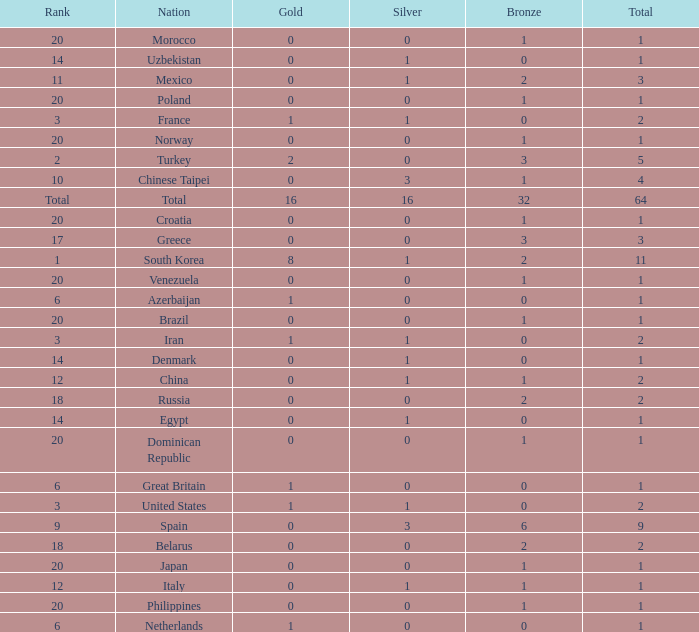Help me parse the entirety of this table. {'header': ['Rank', 'Nation', 'Gold', 'Silver', 'Bronze', 'Total'], 'rows': [['20', 'Morocco', '0', '0', '1', '1'], ['14', 'Uzbekistan', '0', '1', '0', '1'], ['11', 'Mexico', '0', '1', '2', '3'], ['20', 'Poland', '0', '0', '1', '1'], ['3', 'France', '1', '1', '0', '2'], ['20', 'Norway', '0', '0', '1', '1'], ['2', 'Turkey', '2', '0', '3', '5'], ['10', 'Chinese Taipei', '0', '3', '1', '4'], ['Total', 'Total', '16', '16', '32', '64'], ['20', 'Croatia', '0', '0', '1', '1'], ['17', 'Greece', '0', '0', '3', '3'], ['1', 'South Korea', '8', '1', '2', '11'], ['20', 'Venezuela', '0', '0', '1', '1'], ['6', 'Azerbaijan', '1', '0', '0', '1'], ['20', 'Brazil', '0', '0', '1', '1'], ['3', 'Iran', '1', '1', '0', '2'], ['14', 'Denmark', '0', '1', '0', '1'], ['12', 'China', '0', '1', '1', '2'], ['18', 'Russia', '0', '0', '2', '2'], ['14', 'Egypt', '0', '1', '0', '1'], ['20', 'Dominican Republic', '0', '0', '1', '1'], ['6', 'Great Britain', '1', '0', '0', '1'], ['3', 'United States', '1', '1', '0', '2'], ['9', 'Spain', '0', '3', '6', '9'], ['18', 'Belarus', '0', '0', '2', '2'], ['20', 'Japan', '0', '0', '1', '1'], ['12', 'Italy', '0', '1', '1', '1'], ['20', 'Philippines', '0', '0', '1', '1'], ['6', 'Netherlands', '1', '0', '0', '1']]} How many total silvers does Russia have? 1.0. 